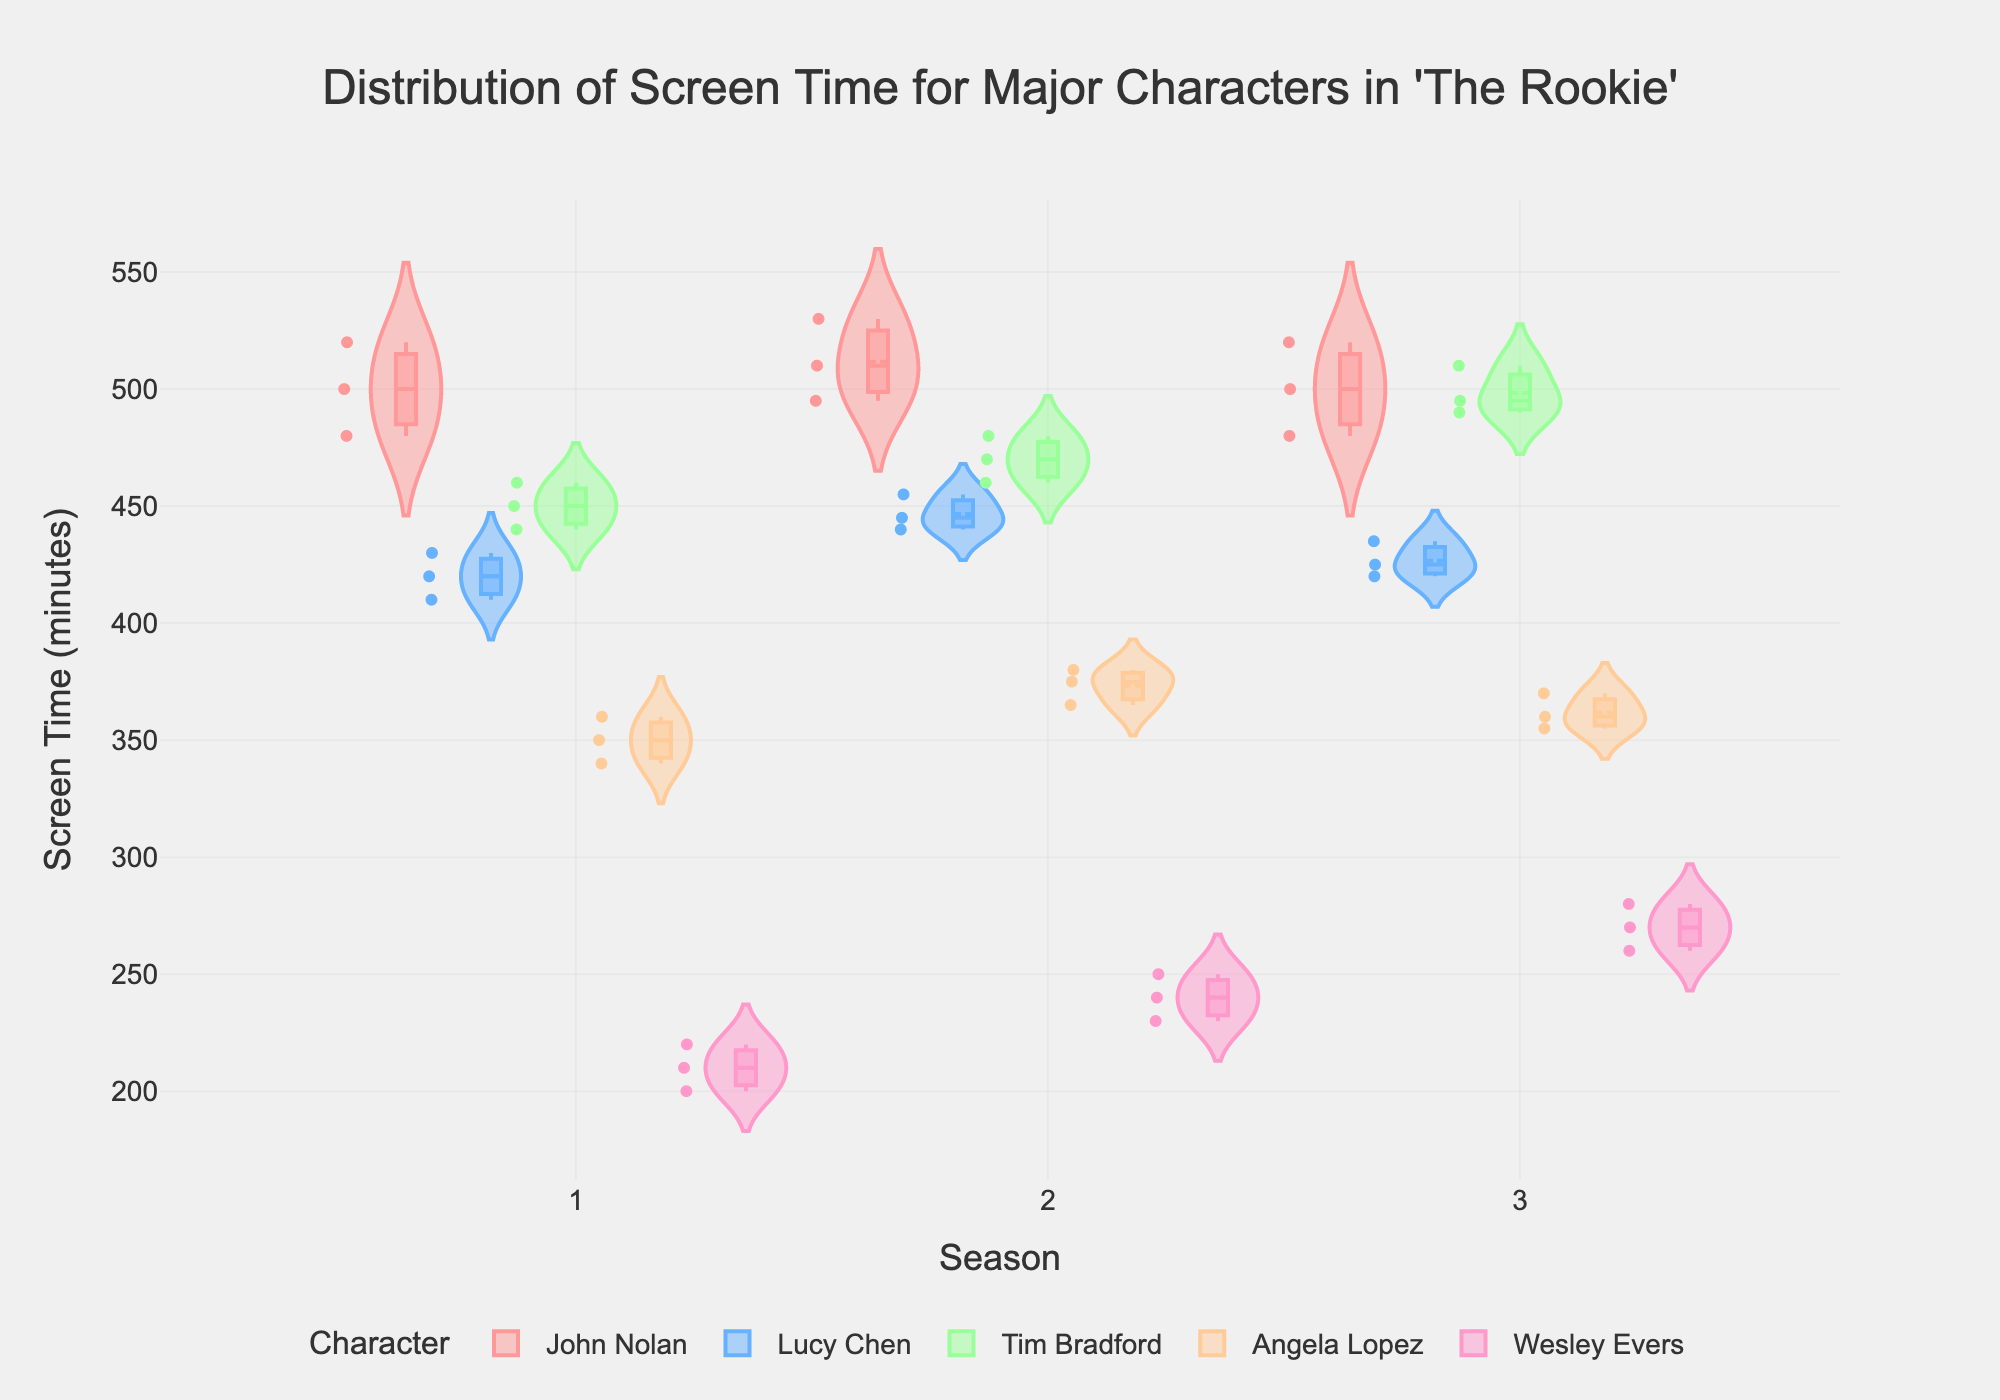Which character has the most screen time variability across seasons? To see which character has the most variability, look for the character whose violins are the widest or have the most spread season to season.
Answer: John Nolan What is the general trend of Tim Bradford's screen time across the seasons? To identify the trend, examine the median lines inside the violins for Tim Bradford for each season and observe if they are increasing or decreasing.
Answer: Increasing How does Lucy Chen's screen time in Season 2 compare to Angela Lopez's in the same season? Compare the medians of Lucy Chen's and Angela Lopez's violins for Season 2 to determine which one is higher.
Answer: Lucy Chen has more screen time than Angela Lopez Which character appears to have the lowest median screen time across all seasons? To find the character with the lowest median screen time, identify the character with the median line lowest on the y-axis across all seasons.
Answer: Wesley Evers What is John Nolan's median screen time in Season 1? Look at the violin for John Nolan in Season 1 and identify the median line within the violin plot.
Answer: 500 minutes Are there any characters whose screen time median decreases from Season 2 to Season 3? Check the median lines in the violin plots for each character from Season 2 to Season 3 to see if any of them decrease.
Answer: Angela Lopez and Lucy Chen Which season has the highest mean screen time for John Nolan? Observe the mean line within the violins for each season for John Nolan and identify the highest one.
Answer: Season 2 Is the range of screen time for Lucy Chen in Season 3 larger or smaller than in Season 1? Compare the width of the violins (the range) for Lucy Chen in Season 3 and Season 1 to see which is larger.
Answer: Smaller Considering all characters, which season has the most consistent screen time distribution (least variability)? Look for the season where the violins for all characters are the narrowest, indicating less variability.
Answer: Season 1 